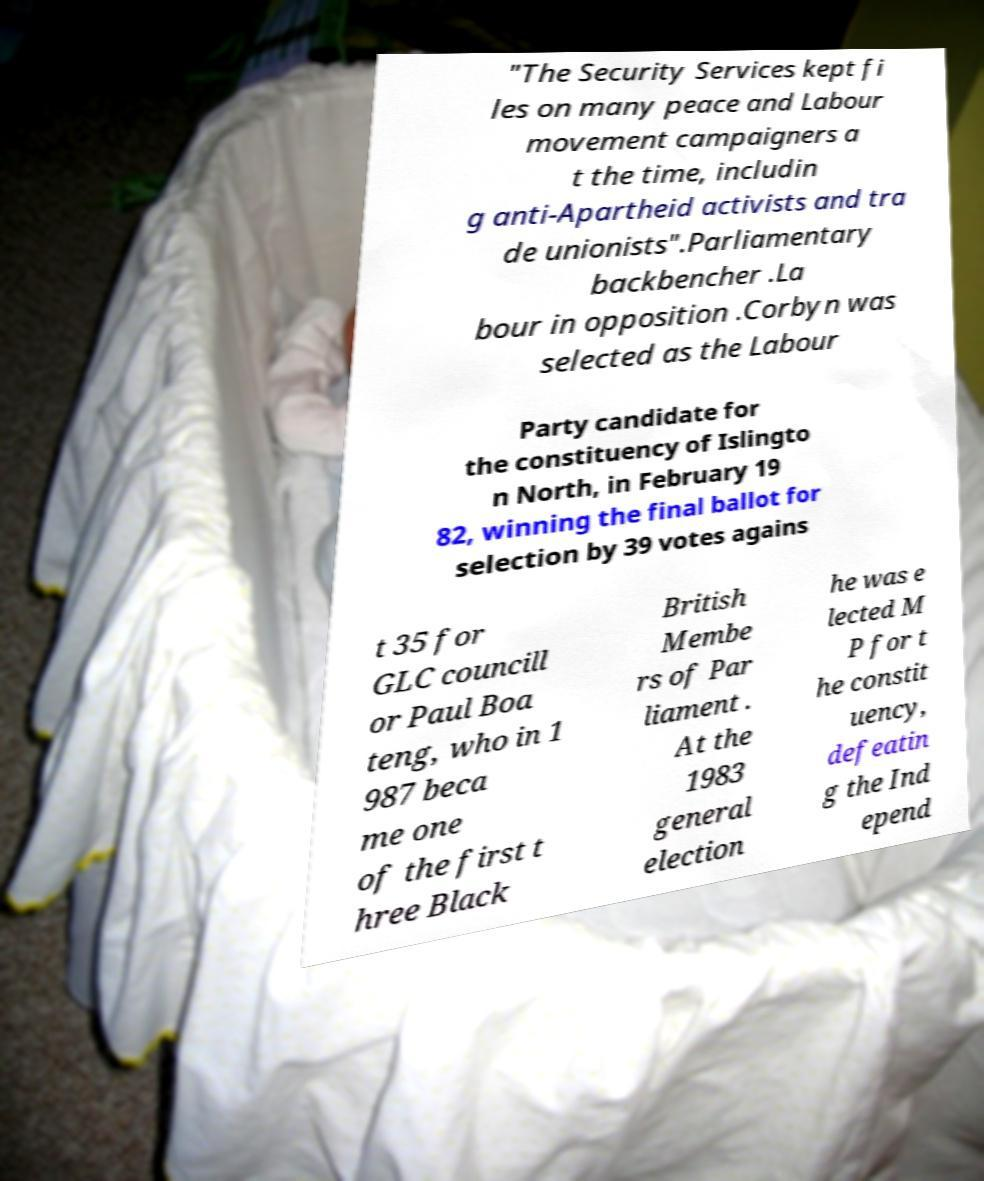Could you extract and type out the text from this image? "The Security Services kept fi les on many peace and Labour movement campaigners a t the time, includin g anti-Apartheid activists and tra de unionists".Parliamentary backbencher .La bour in opposition .Corbyn was selected as the Labour Party candidate for the constituency of Islingto n North, in February 19 82, winning the final ballot for selection by 39 votes agains t 35 for GLC councill or Paul Boa teng, who in 1 987 beca me one of the first t hree Black British Membe rs of Par liament . At the 1983 general election he was e lected M P for t he constit uency, defeatin g the Ind epend 